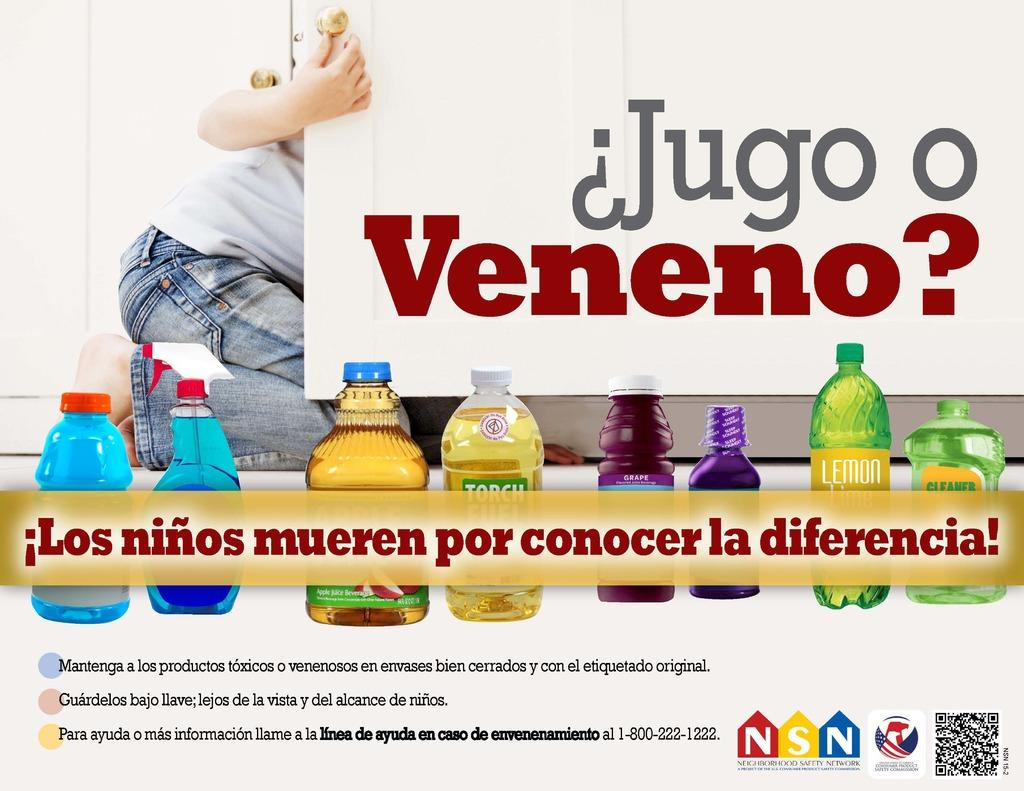Provide a one-sentence caption for the provided image. A person in jeans is behind a cabinet that says Jugo o Veneno. 